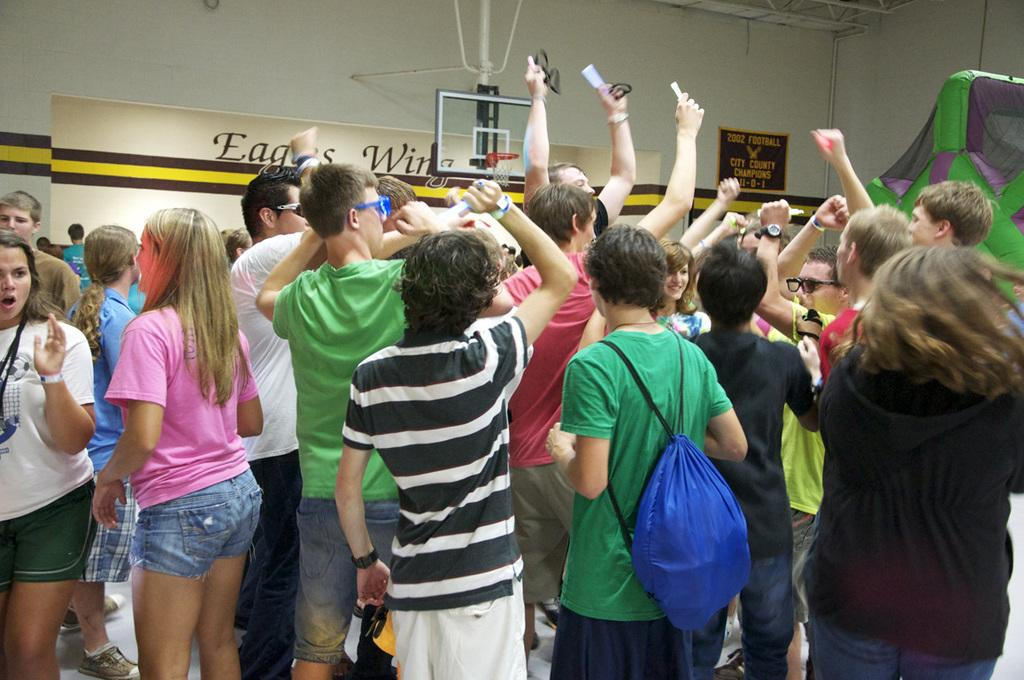What is happening in the image? There is a group of people in the image, and some of them are holding cameras. What are the people with cameras doing? The people holding cameras are capturing the group. What type of chain can be seen hanging from the canvas in the image? There is no chain or canvas present in the image; it features a group of people and people holding cameras. 